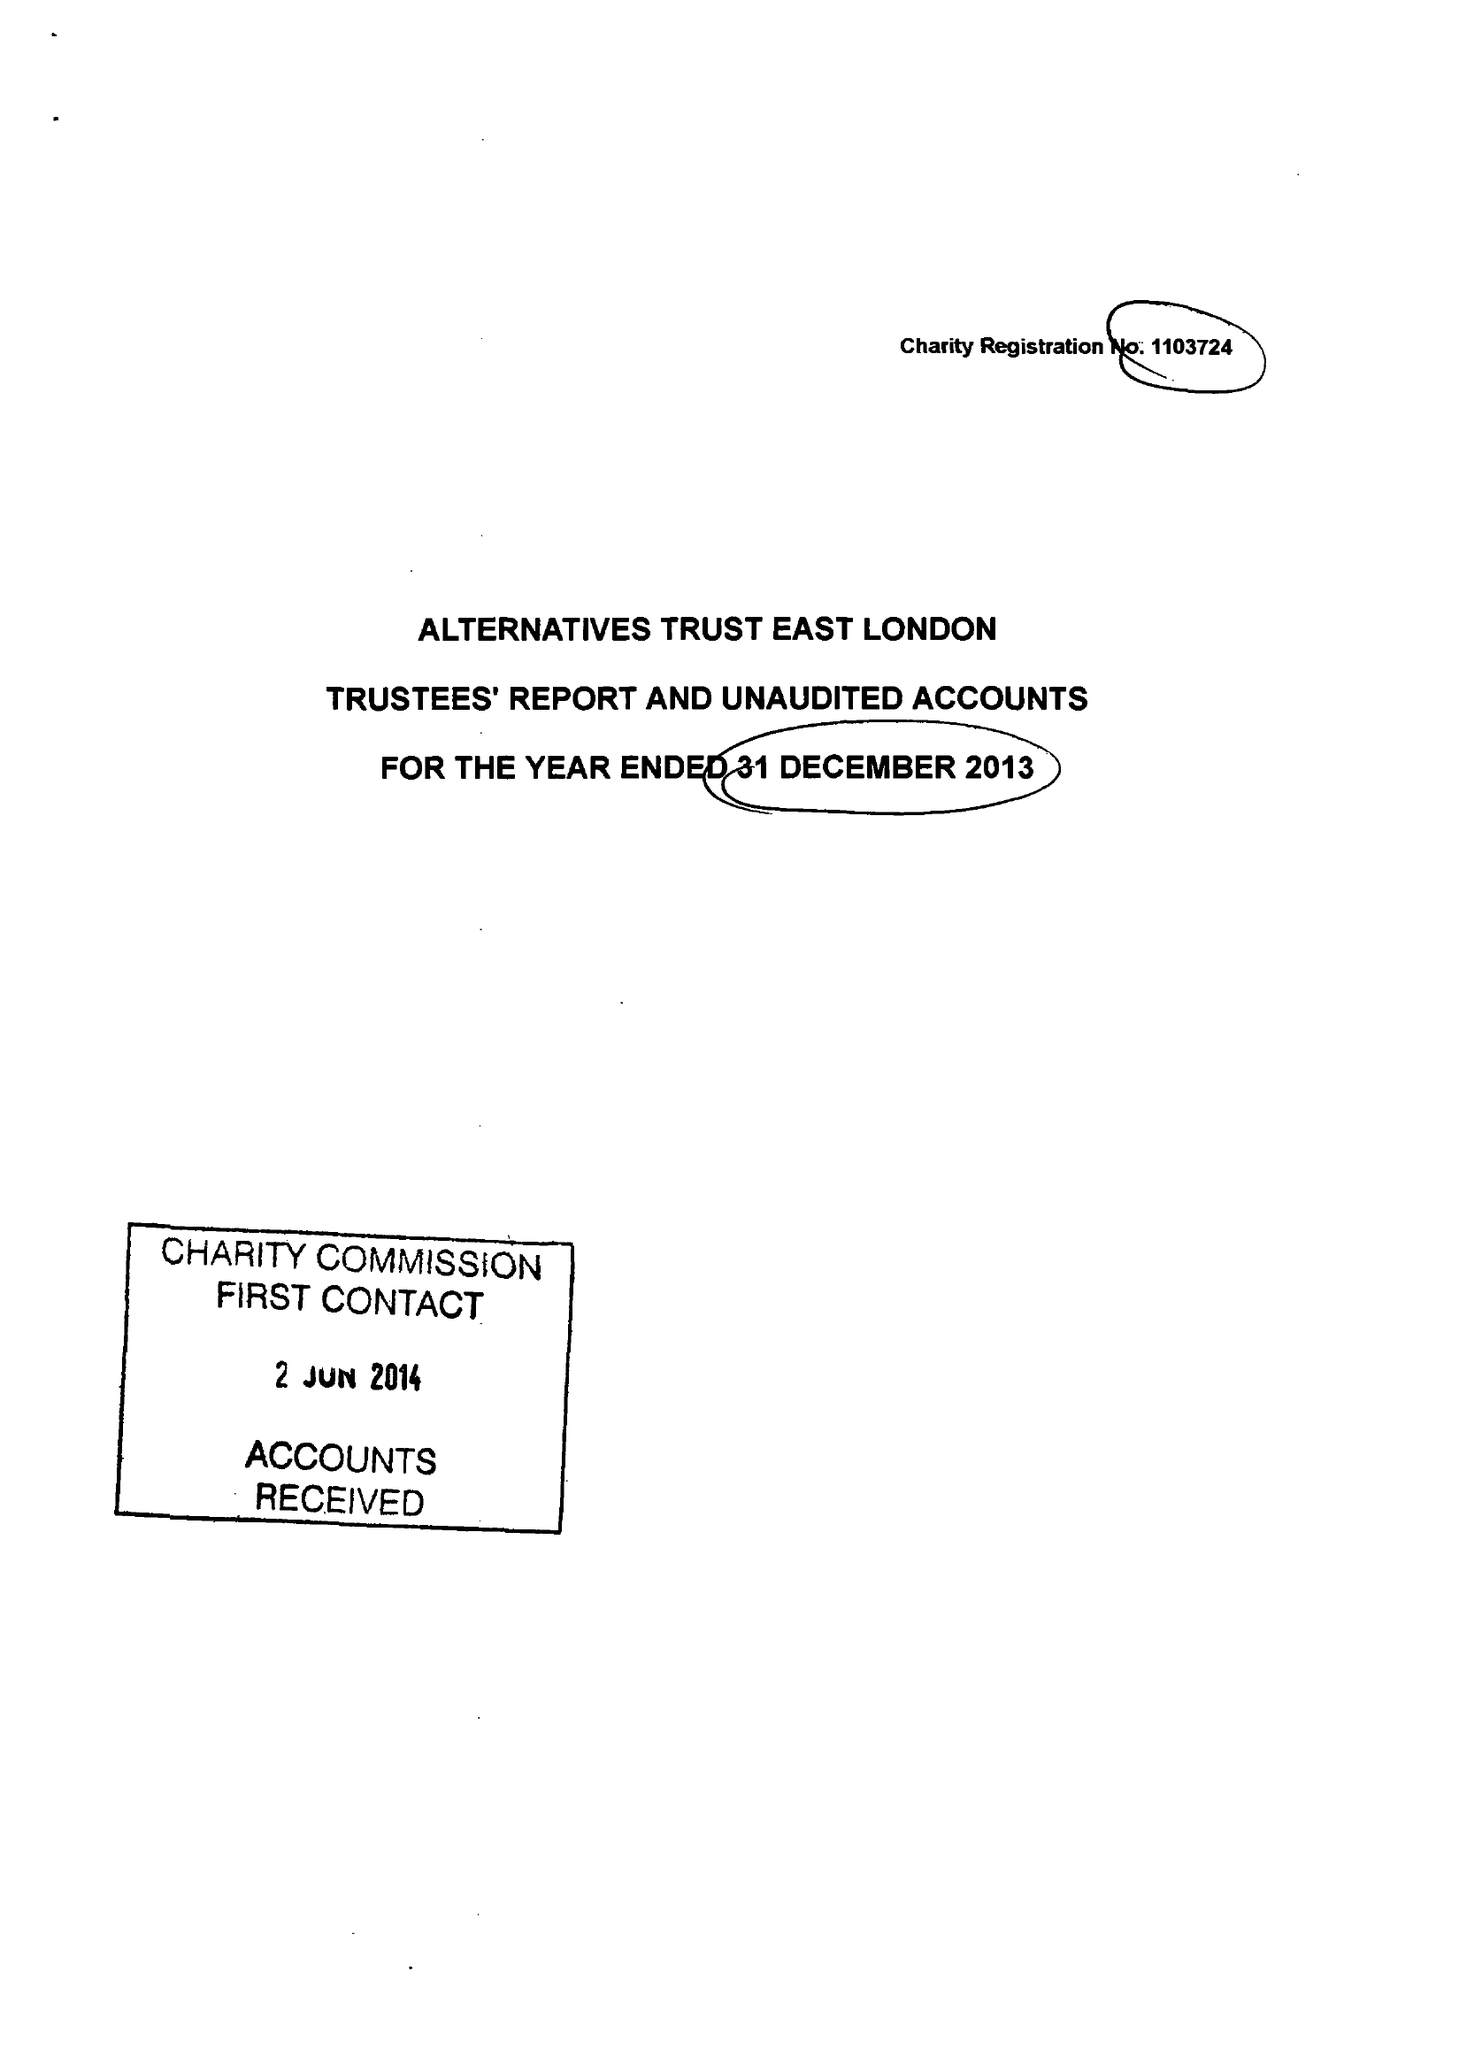What is the value for the address__post_town?
Answer the question using a single word or phrase. LONDON 